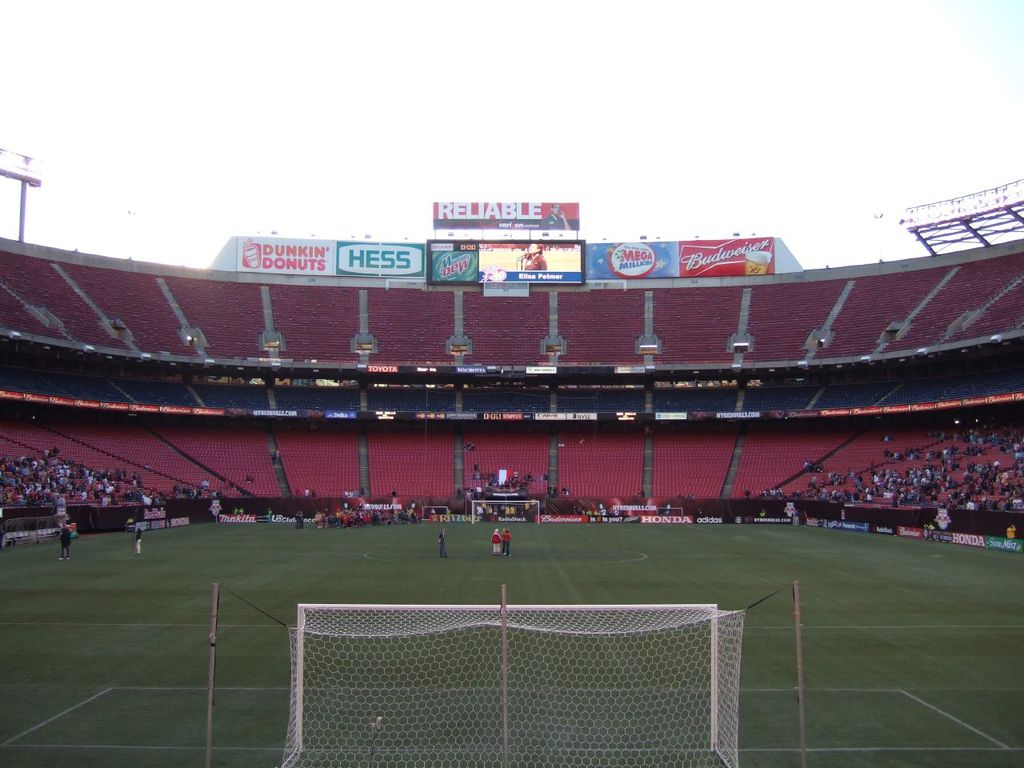What do the advertisements in the background tell us about the sponsorships in sports events? The diverse range of advertisements, from food and beverages to automotive and energy companies, highlights the broad corporate interest in sports events for brand visibility and audience engagement. 